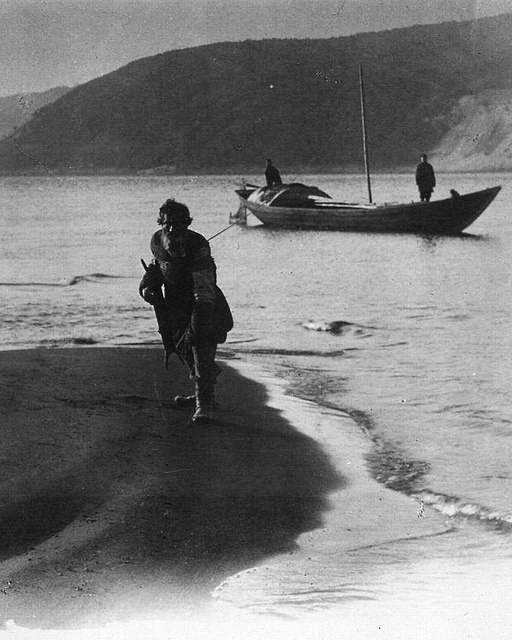Describe the objects in this image and their specific colors. I can see people in darkgray, black, gray, and lightgray tones, boat in darkgray, black, gray, and lightgray tones, horse in darkgray, black, gray, and lightgray tones, people in darkgray, black, gray, and lightgray tones, and people in black, gray, and darkgray tones in this image. 